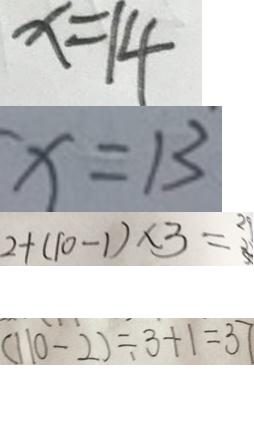Convert formula to latex. <formula><loc_0><loc_0><loc_500><loc_500>x = 1 4 
 x = 1 3 
 2 + ( 1 0 - 1 ) \times 3 = 2 9 
 ( 1 1 0 - 2 ) \div 3 + 1 = 3 7</formula> 